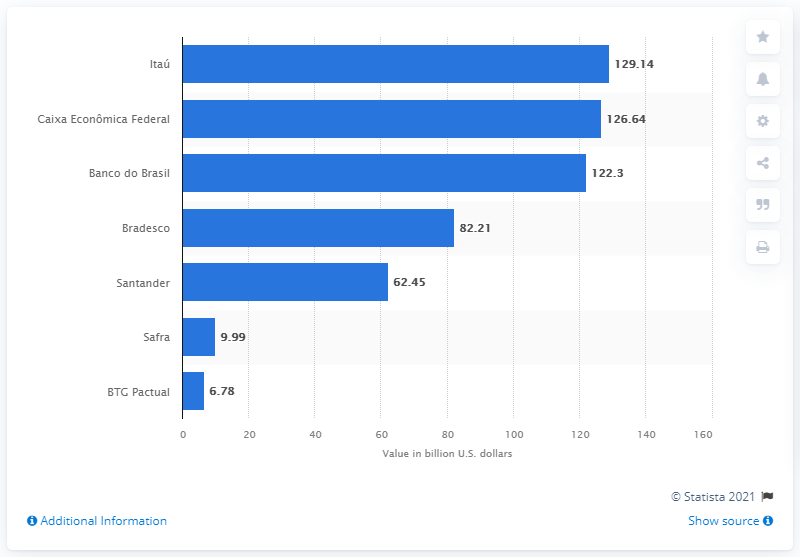Can you tell me the deposit amounts for the two banks with the highest deposits as shown in this image? Certainly, the two banks with the highest deposits according to the image are Itaú, with deposits of 129.14 billion U.S. dollars, and Caixa Econômica Federal, with 126.64 billion U.S. dollars. 